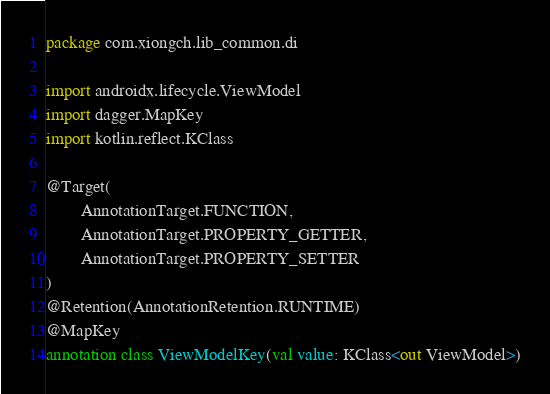<code> <loc_0><loc_0><loc_500><loc_500><_Kotlin_>package com.xiongch.lib_common.di

import androidx.lifecycle.ViewModel
import dagger.MapKey
import kotlin.reflect.KClass

@Target(
        AnnotationTarget.FUNCTION,
        AnnotationTarget.PROPERTY_GETTER,
        AnnotationTarget.PROPERTY_SETTER
)
@Retention(AnnotationRetention.RUNTIME)
@MapKey
annotation class ViewModelKey(val value: KClass<out ViewModel>)</code> 